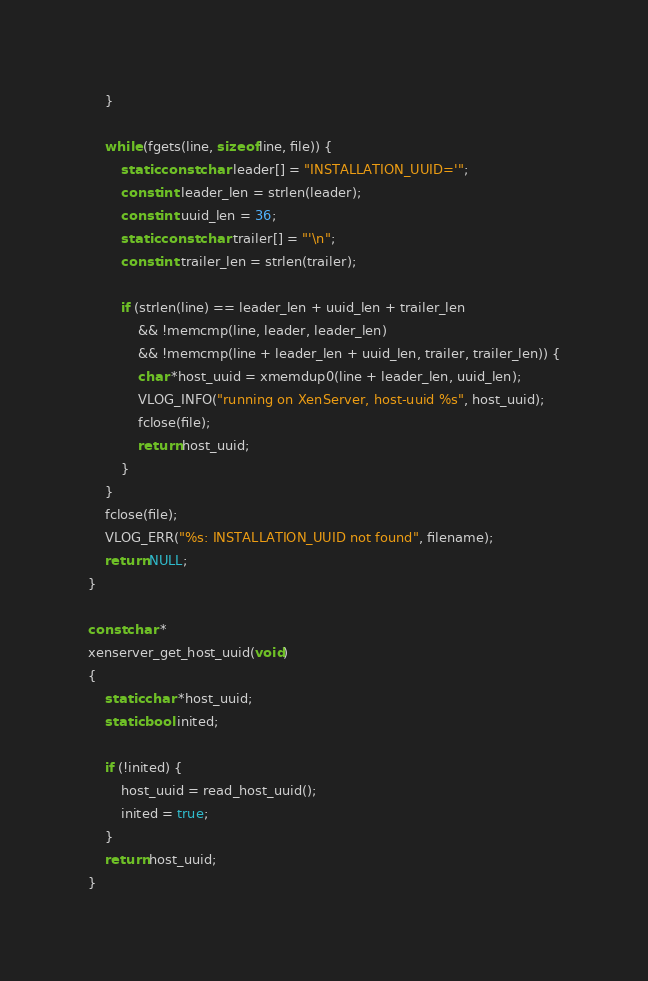Convert code to text. <code><loc_0><loc_0><loc_500><loc_500><_C_>    }

    while (fgets(line, sizeof line, file)) {
        static const char leader[] = "INSTALLATION_UUID='";
        const int leader_len = strlen(leader);
        const int uuid_len = 36;
        static const char trailer[] = "'\n";
        const int trailer_len = strlen(trailer);

        if (strlen(line) == leader_len + uuid_len + trailer_len
            && !memcmp(line, leader, leader_len)
            && !memcmp(line + leader_len + uuid_len, trailer, trailer_len)) {
            char *host_uuid = xmemdup0(line + leader_len, uuid_len);
            VLOG_INFO("running on XenServer, host-uuid %s", host_uuid);
            fclose(file);
            return host_uuid;
        }
    }
    fclose(file);
    VLOG_ERR("%s: INSTALLATION_UUID not found", filename);
    return NULL;
}

const char *
xenserver_get_host_uuid(void)
{
    static char *host_uuid;
    static bool inited;

    if (!inited) {
        host_uuid = read_host_uuid();
        inited = true;
    }
    return host_uuid;
}

</code> 